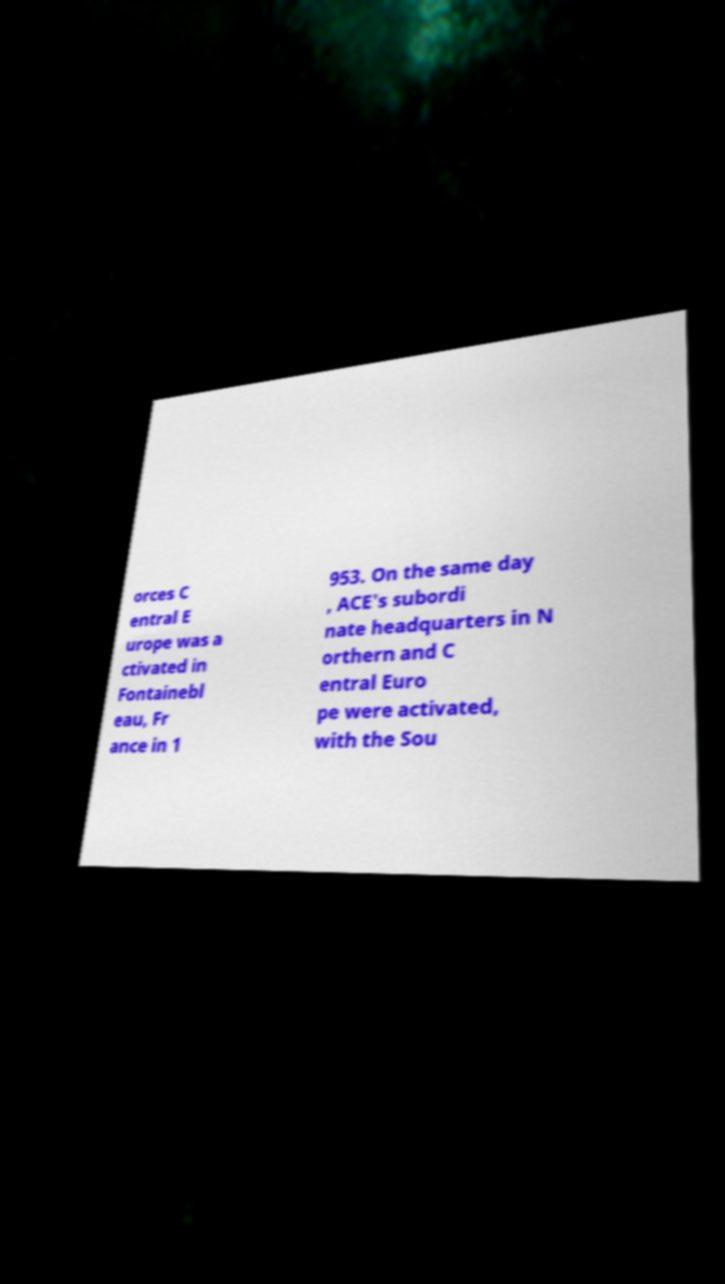I need the written content from this picture converted into text. Can you do that? orces C entral E urope was a ctivated in Fontainebl eau, Fr ance in 1 953. On the same day , ACE's subordi nate headquarters in N orthern and C entral Euro pe were activated, with the Sou 